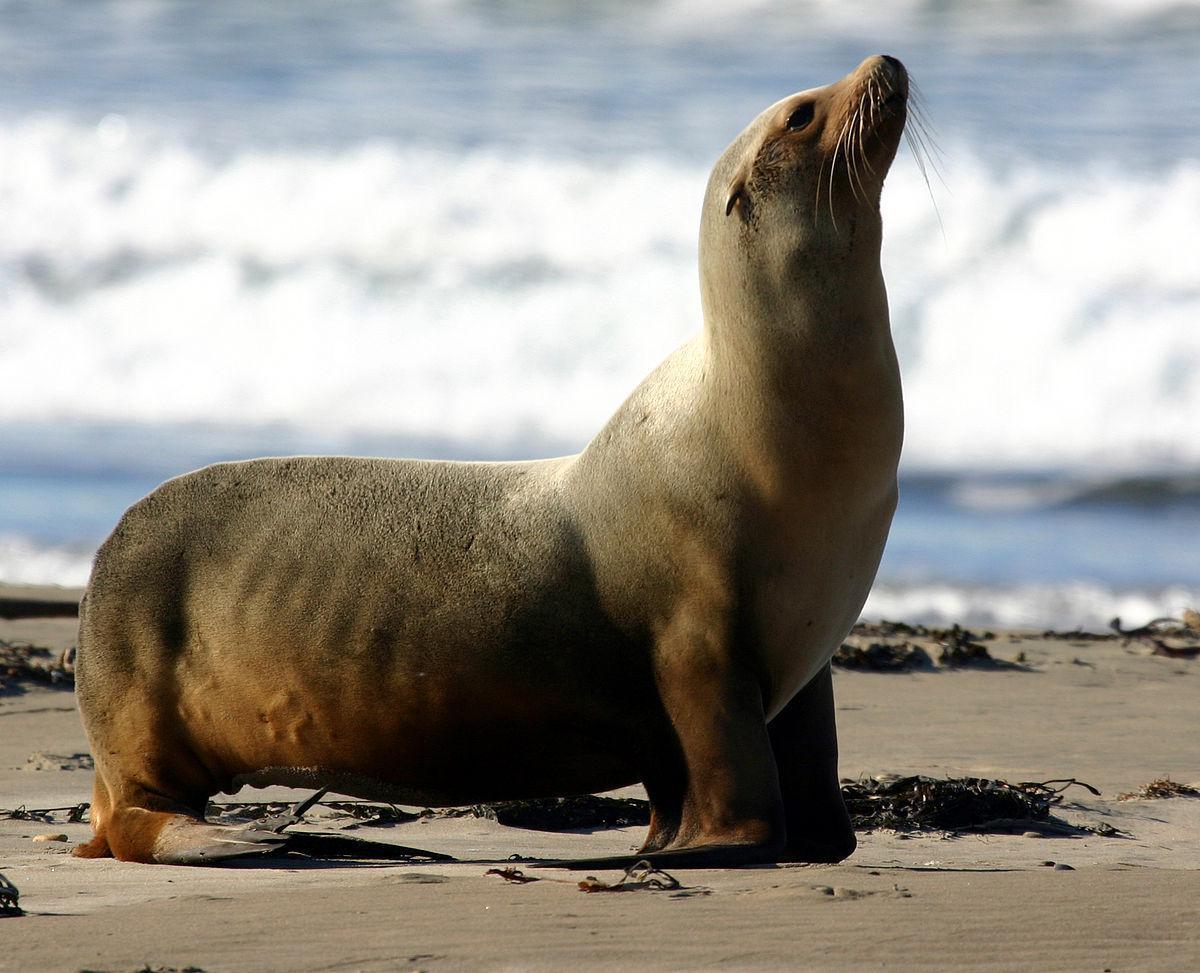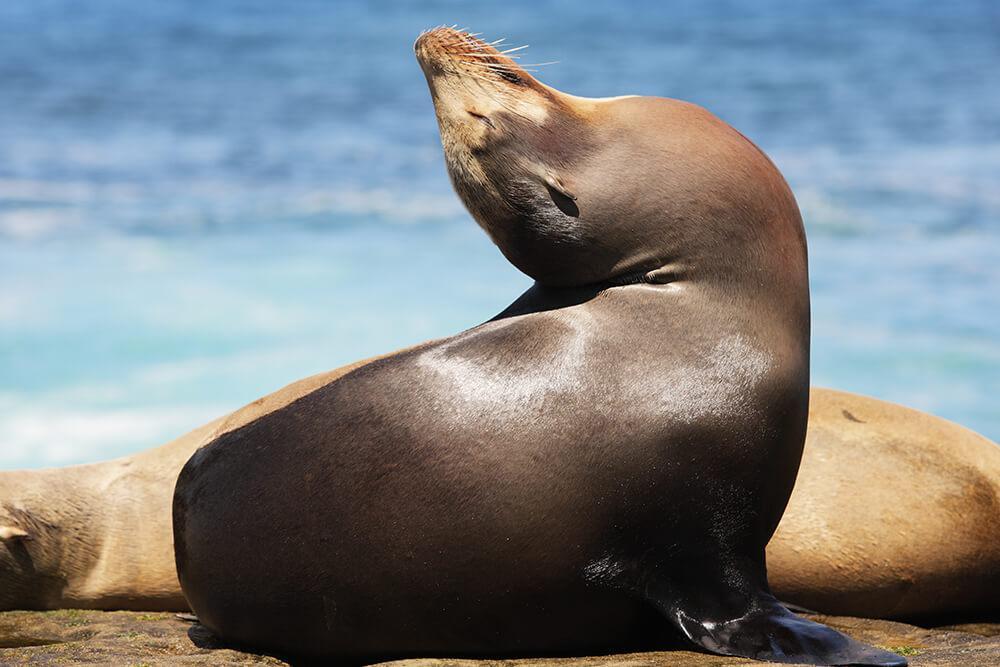The first image is the image on the left, the second image is the image on the right. For the images displayed, is the sentence "Three toes can be counted in the image on the left." factually correct? Answer yes or no. No. The first image is the image on the left, the second image is the image on the right. Analyze the images presented: Is the assertion "At least one image shows a seal on the edge of a man-made pool." valid? Answer yes or no. No. The first image is the image on the left, the second image is the image on the right. Analyze the images presented: Is the assertion "There is more than one seal in at least one image." valid? Answer yes or no. Yes. 